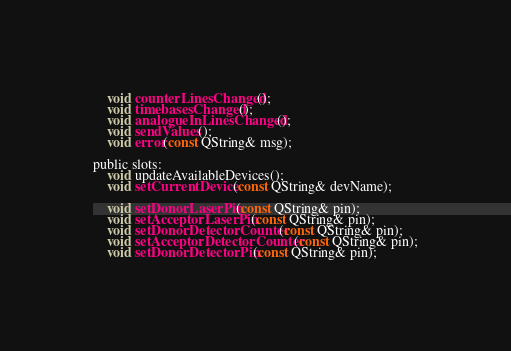Convert code to text. <code><loc_0><loc_0><loc_500><loc_500><_C_>    void counterLinesChanged();
    void timebasesChanged();
    void analogueInLinesChanged();
    void sendValues();
    void error(const QString& msg);

public slots:
    void updateAvailableDevices();
    void setCurrentDevice(const QString& devName);

    void setDonorLaserPin(const QString& pin);
    void setAcceptorLaserPin(const QString& pin);
    void setDonorDetectorCounter(const QString& pin);
    void setAcceptorDetectorCounter(const QString& pin);
    void setDonorDetectorPin(const QString& pin);</code> 